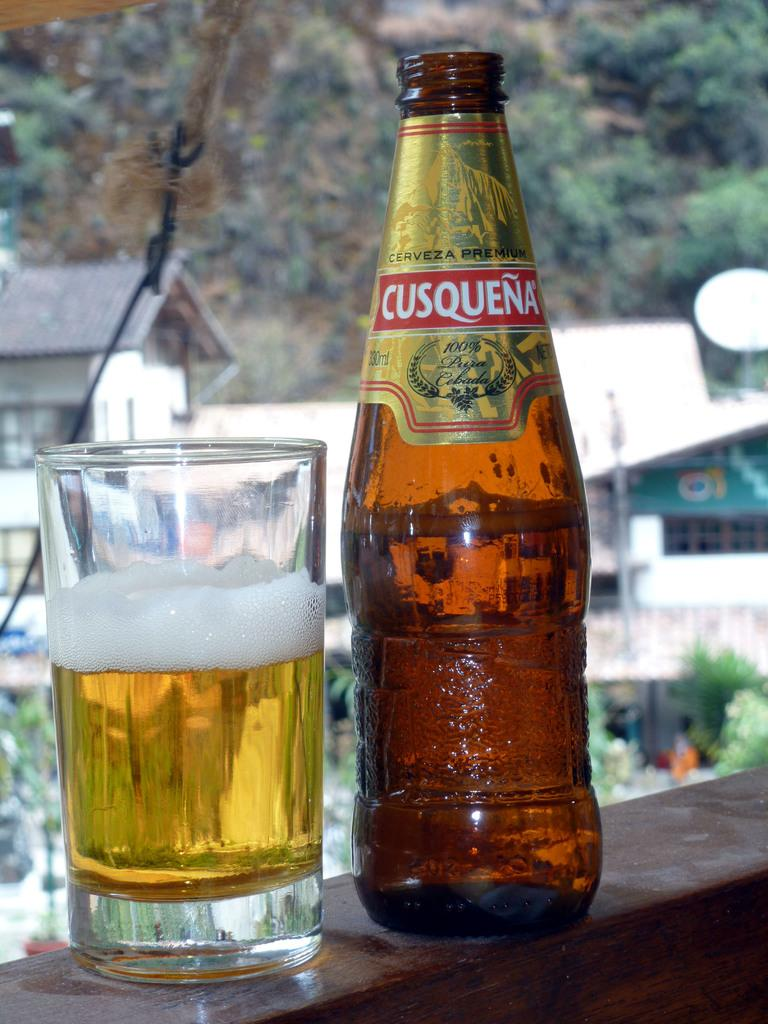<image>
Create a compact narrative representing the image presented. A cool bottle of Cusquena sits beside a glass half poured. 